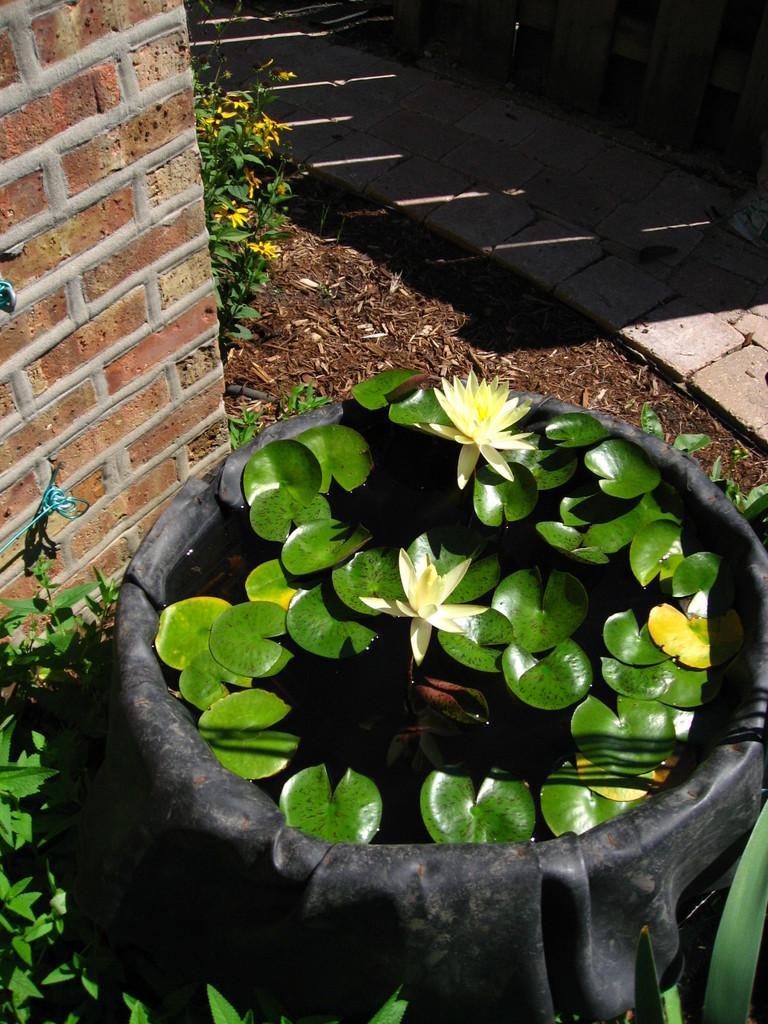How would you summarize this image in a sentence or two? In this image there is a tub, in that there are water plants and flowers, around the tub there are plants and there is a wall, beside the wall there is a land and a path. 